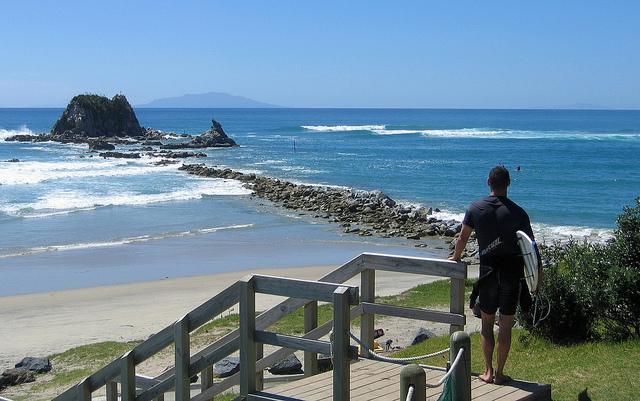Where are the best place in the world to surf?
Give a very brief answer. Hawaii. What is the man standing on?
Concise answer only. Wood. How many people in picture?
Answer briefly. 1. 